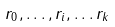Convert formula to latex. <formula><loc_0><loc_0><loc_500><loc_500>r _ { 0 } , \dots , r _ { i } , \dots r _ { k }</formula> 